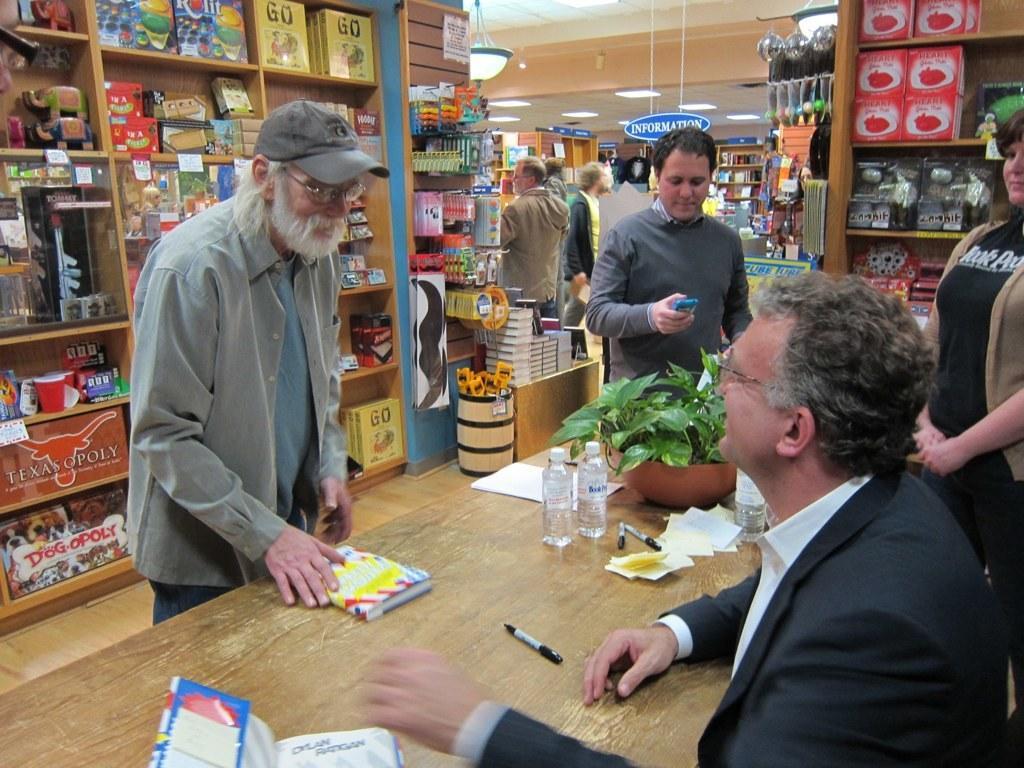Please provide a concise description of this image. In the picture it looks like a store and there are different types of objects kept in the shelves and there is a person sitting in front of the table and around him there are three people, on the table there are few bottles, papers and pens. 